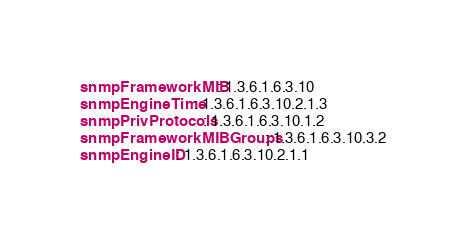Convert code to text. <code><loc_0><loc_0><loc_500><loc_500><_YAML_>snmpFrameworkMIB: 1.3.6.1.6.3.10
snmpEngineTime: 1.3.6.1.6.3.10.2.1.3
snmpPrivProtocols: 1.3.6.1.6.3.10.1.2
snmpFrameworkMIBGroups: 1.3.6.1.6.3.10.3.2
snmpEngineID: 1.3.6.1.6.3.10.2.1.1
</code> 